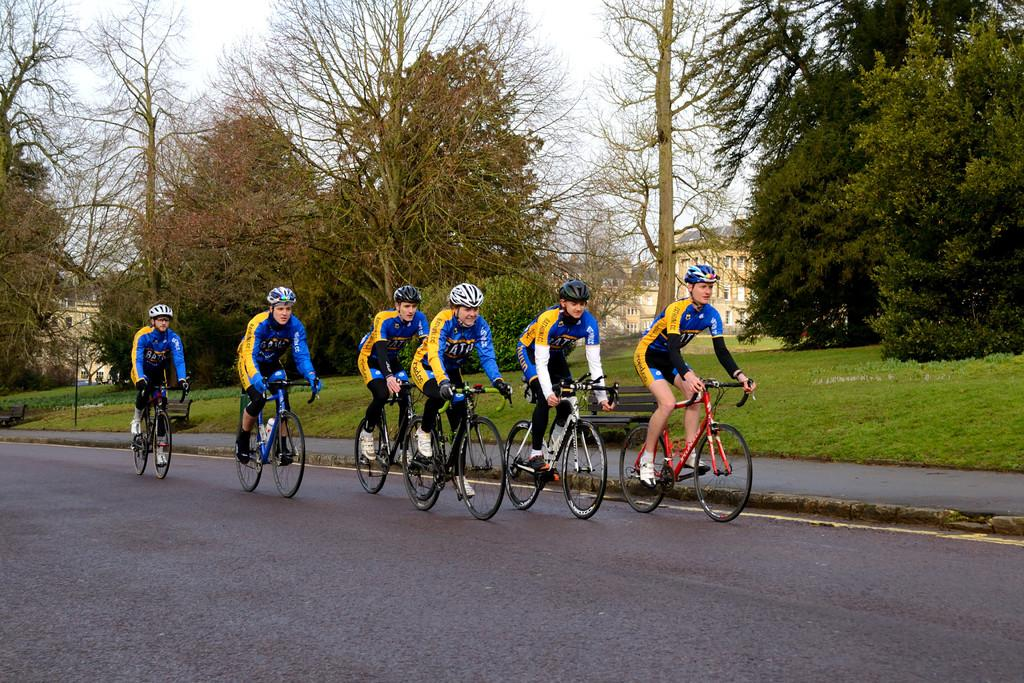Where is the image located? The image is on a road. What are the people in the image doing? The people in the image are riding cycles. What are the people wearing in the image? The people are wearing blue jackets and helmets. What can be seen in the background of the image? There are trees and a building in the background of the image. What type of sail can be seen on the cycles in the image? There are no sails present on the cycles in the image. What is the size of the newsstand in the image? There is no newsstand present in the image. 